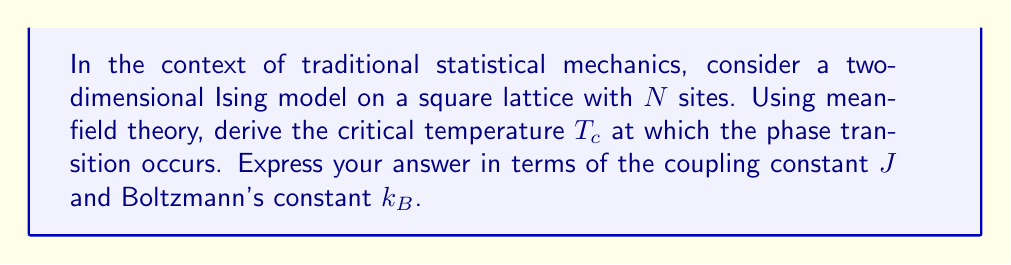Give your solution to this math problem. 1. In mean-field theory, we assume each spin interacts with an average field produced by its neighbors. For a square lattice, each spin has 4 nearest neighbors.

2. The mean-field Hamiltonian for a single spin is:
   $$H = -J z m s_i - h s_i$$
   where $z=4$ is the coordination number, $m$ is the average magnetization, and $h$ is the external field.

3. The partition function for a single spin is:
   $$Z = e^{\beta J z m + \beta h} + e^{-\beta J z m - \beta h}$$
   where $\beta = \frac{1}{k_B T}$.

4. The average magnetization is given by:
   $$m = \tanh(\beta J z m + \beta h)$$

5. For zero external field ($h=0$), this becomes:
   $$m = \tanh(\beta J z m)$$

6. Near the critical point, $m$ is small, so we can expand $\tanh(x) \approx x - \frac{1}{3}x^3$:
   $$m \approx \beta J z m - \frac{1}{3}(\beta J z m)^3$$

7. Rearranging:
   $$m(\beta J z - 1) + \frac{1}{3}(\beta J z)^3 m^3 = 0$$

8. For a non-zero solution, we must have:
   $$\beta J z - 1 = 0$$

9. Solving for $T$:
   $$T_c = \frac{J z}{k_B} = \frac{4J}{k_B}$$
Answer: $T_c = \frac{4J}{k_B}$ 